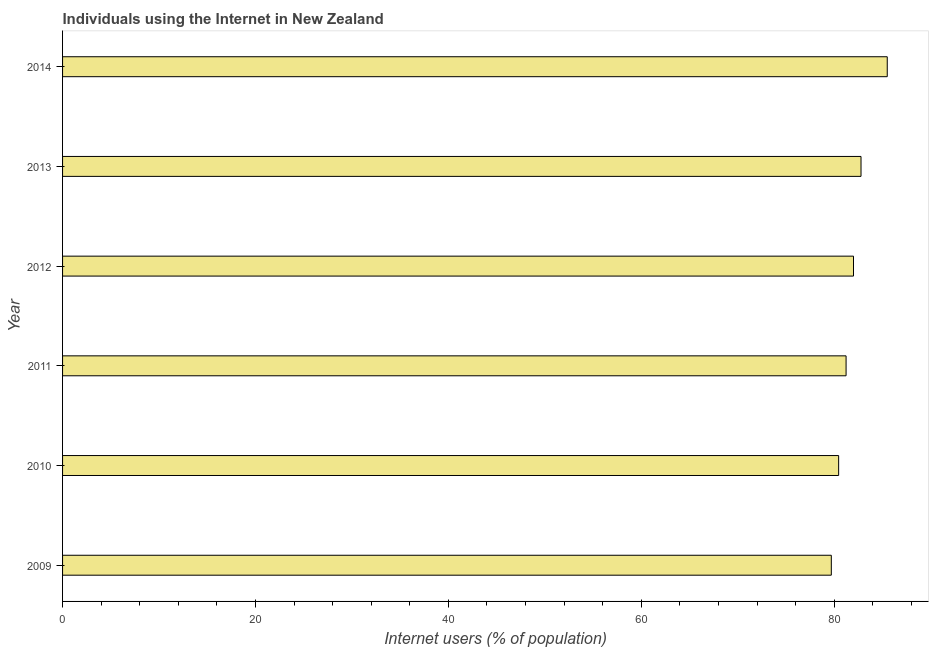Does the graph contain grids?
Ensure brevity in your answer.  No. What is the title of the graph?
Provide a short and direct response. Individuals using the Internet in New Zealand. What is the label or title of the X-axis?
Your answer should be very brief. Internet users (% of population). What is the number of internet users in 2011?
Provide a short and direct response. 81.23. Across all years, what is the maximum number of internet users?
Your answer should be compact. 85.5. Across all years, what is the minimum number of internet users?
Offer a very short reply. 79.7. What is the sum of the number of internet users?
Provide a short and direct response. 491.67. What is the average number of internet users per year?
Make the answer very short. 81.94. What is the median number of internet users?
Offer a terse response. 81.62. In how many years, is the number of internet users greater than 72 %?
Your answer should be very brief. 6. Is the number of internet users in 2009 less than that in 2013?
Provide a succinct answer. Yes. Is the difference between the number of internet users in 2010 and 2013 greater than the difference between any two years?
Keep it short and to the point. No. What is the difference between the highest and the second highest number of internet users?
Your response must be concise. 2.72. Is the sum of the number of internet users in 2010 and 2012 greater than the maximum number of internet users across all years?
Provide a succinct answer. Yes. What is the difference between the highest and the lowest number of internet users?
Ensure brevity in your answer.  5.8. In how many years, is the number of internet users greater than the average number of internet users taken over all years?
Make the answer very short. 3. What is the difference between two consecutive major ticks on the X-axis?
Your answer should be compact. 20. Are the values on the major ticks of X-axis written in scientific E-notation?
Give a very brief answer. No. What is the Internet users (% of population) in 2009?
Provide a short and direct response. 79.7. What is the Internet users (% of population) in 2010?
Give a very brief answer. 80.46. What is the Internet users (% of population) in 2011?
Give a very brief answer. 81.23. What is the Internet users (% of population) in 2013?
Offer a very short reply. 82.78. What is the Internet users (% of population) of 2014?
Offer a very short reply. 85.5. What is the difference between the Internet users (% of population) in 2009 and 2010?
Offer a terse response. -0.76. What is the difference between the Internet users (% of population) in 2009 and 2011?
Your answer should be compact. -1.53. What is the difference between the Internet users (% of population) in 2009 and 2012?
Provide a succinct answer. -2.3. What is the difference between the Internet users (% of population) in 2009 and 2013?
Your answer should be very brief. -3.08. What is the difference between the Internet users (% of population) in 2009 and 2014?
Provide a short and direct response. -5.8. What is the difference between the Internet users (% of population) in 2010 and 2011?
Offer a terse response. -0.77. What is the difference between the Internet users (% of population) in 2010 and 2012?
Your response must be concise. -1.54. What is the difference between the Internet users (% of population) in 2010 and 2013?
Provide a succinct answer. -2.32. What is the difference between the Internet users (% of population) in 2010 and 2014?
Your response must be concise. -5.04. What is the difference between the Internet users (% of population) in 2011 and 2012?
Provide a succinct answer. -0.77. What is the difference between the Internet users (% of population) in 2011 and 2013?
Provide a succinct answer. -1.55. What is the difference between the Internet users (% of population) in 2011 and 2014?
Keep it short and to the point. -4.27. What is the difference between the Internet users (% of population) in 2012 and 2013?
Provide a succinct answer. -0.78. What is the difference between the Internet users (% of population) in 2012 and 2014?
Offer a very short reply. -3.5. What is the difference between the Internet users (% of population) in 2013 and 2014?
Your response must be concise. -2.72. What is the ratio of the Internet users (% of population) in 2009 to that in 2011?
Give a very brief answer. 0.98. What is the ratio of the Internet users (% of population) in 2009 to that in 2013?
Your answer should be very brief. 0.96. What is the ratio of the Internet users (% of population) in 2009 to that in 2014?
Offer a very short reply. 0.93. What is the ratio of the Internet users (% of population) in 2010 to that in 2011?
Make the answer very short. 0.99. What is the ratio of the Internet users (% of population) in 2010 to that in 2012?
Your response must be concise. 0.98. What is the ratio of the Internet users (% of population) in 2010 to that in 2013?
Your answer should be compact. 0.97. What is the ratio of the Internet users (% of population) in 2010 to that in 2014?
Offer a terse response. 0.94. What is the ratio of the Internet users (% of population) in 2011 to that in 2014?
Offer a very short reply. 0.95. What is the ratio of the Internet users (% of population) in 2012 to that in 2013?
Give a very brief answer. 0.99. What is the ratio of the Internet users (% of population) in 2013 to that in 2014?
Provide a succinct answer. 0.97. 